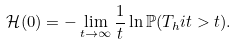Convert formula to latex. <formula><loc_0><loc_0><loc_500><loc_500>\mathcal { H } ( 0 ) = - \lim _ { t \to \infty } \frac { 1 } { t } \ln \mathbb { P } ( T _ { h } i t > t ) .</formula> 